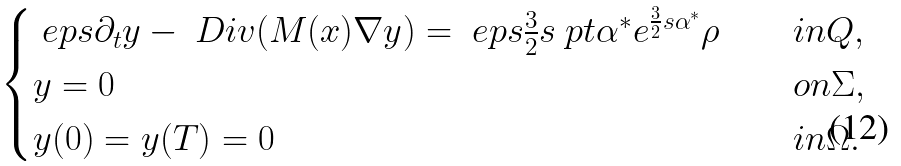<formula> <loc_0><loc_0><loc_500><loc_500>\begin{cases} \ e p s \partial _ { t } y - \ D i v ( M ( x ) \nabla y ) = \ e p s \frac { 3 } { 2 } s \ p t \alpha ^ { * } e ^ { \frac { 3 } { 2 } s \alpha ^ { * } } \rho & \quad i n Q , \\ y = 0 & \quad o n \Sigma , \\ y ( 0 ) = y ( T ) = 0 & \quad i n \Omega . \end{cases}</formula> 